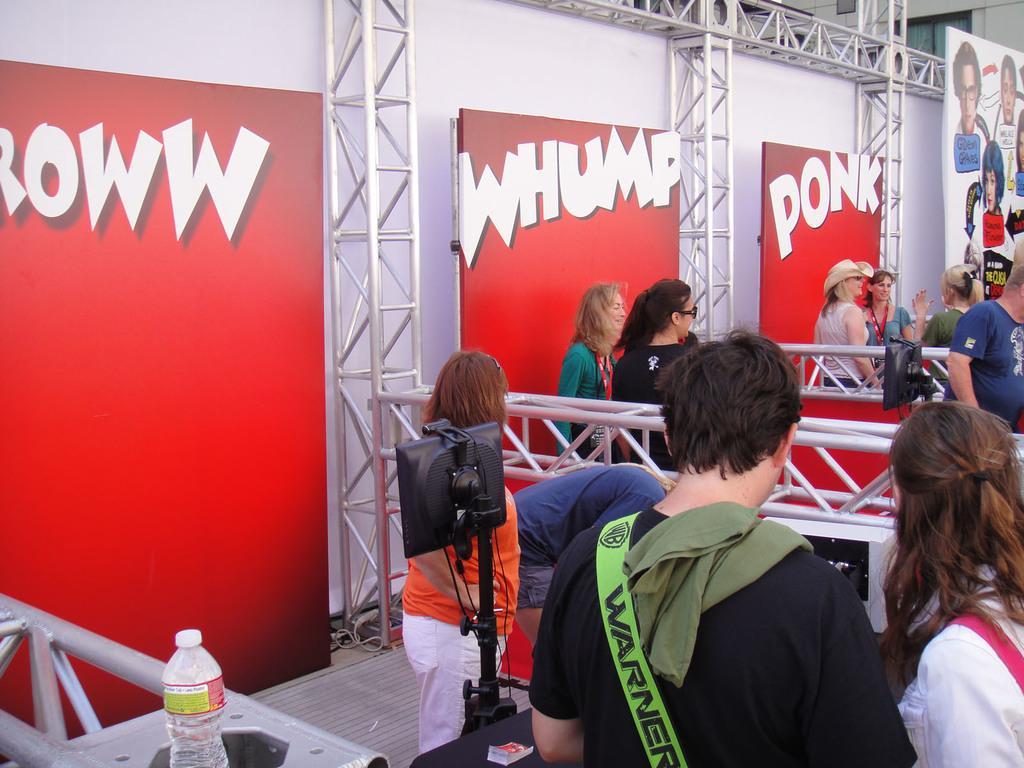Describe this image in one or two sentences. In this image there are persons standing and in the front there is a bottle. There are stands there are boards with some text and images on it and there is an object which is black in colour which is in the center and there is partition board which is white in colour. 